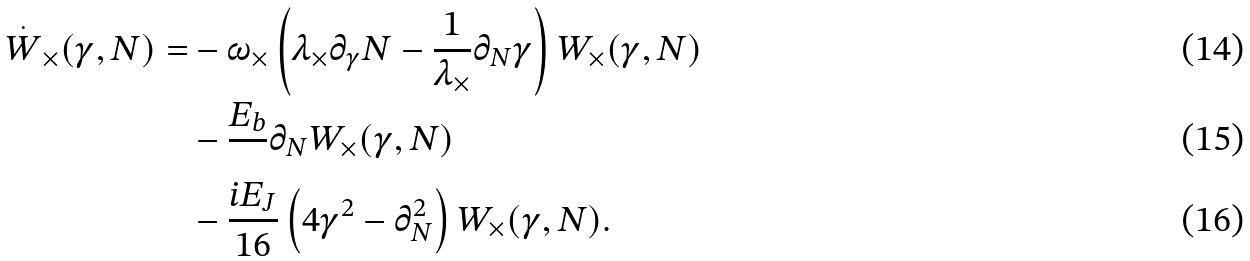<formula> <loc_0><loc_0><loc_500><loc_500>\overset { . } { W } _ { \times } ( \gamma , N ) = & - \omega _ { \times } \left ( \lambda _ { \times } \partial _ { \gamma } N - \frac { 1 } { \lambda _ { \times } } \partial _ { N } \gamma \right ) W _ { \times } ( \gamma , N ) \\ & - \frac { E _ { b } } { } \partial _ { N } W _ { \times } ( \gamma , N ) \\ & - \frac { i E _ { J } } { 1 6 } \left ( 4 \gamma ^ { 2 } - \partial _ { N } ^ { 2 } \right ) W _ { \times } ( \gamma , N ) .</formula> 